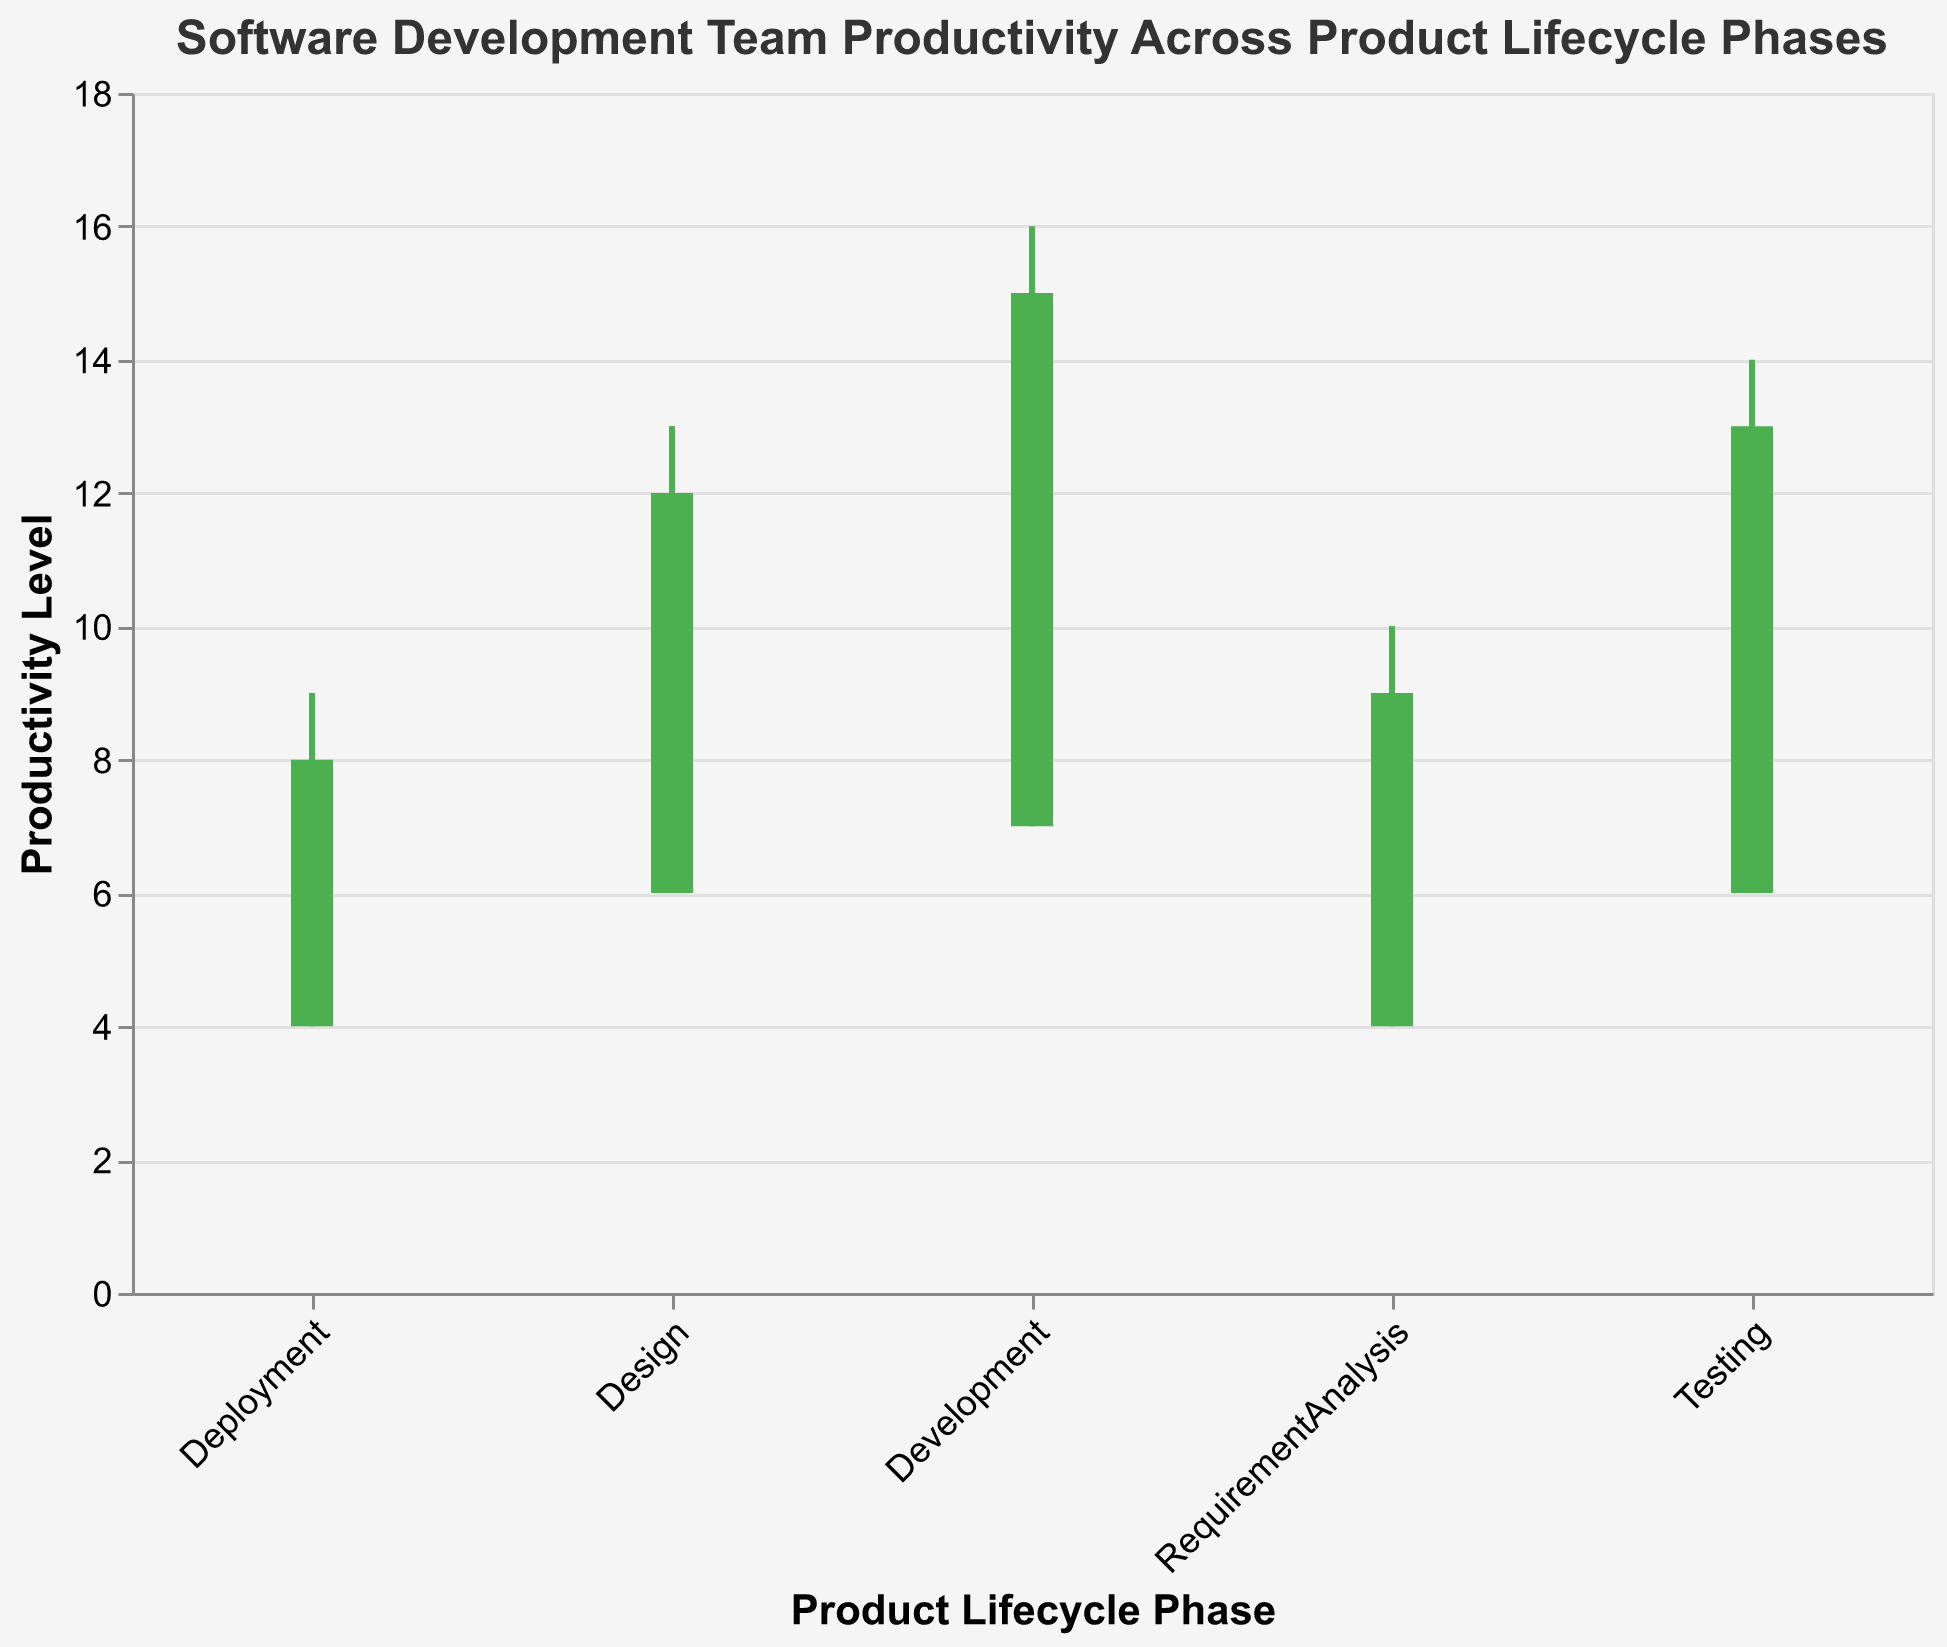What does the green color indicate in the candlestick plot? The green color in the candlestick plot indicates periods where the Close value is higher than the Open value, signifying an increase in productivity.
Answer: Increase in productivity What phase has the highest recorded productivity level? To find the highest productivity level, we look at the High values across all phases. The Development phase has the highest High value of 16.
Answer: Development What is the title of the plot? The title of the plot is directly displayed at the top of the figure.
Answer: Software Development Team Productivity Across Product Lifecycle Phases Which phase has the smallest range in productivity levels? The range of productivity levels can be found by subtracting the Low value from the High value. By checking each phase: RequirementAnalysis (10 - 4 = 6), Design (13 - 6 = 7), Development (16 - 7 = 9), Testing (14 - 6 = 8), Deployment (9 - 4 = 5). Deployment has the smallest range of 5
Answer: Deployment On average, how does productivity compare between the Design and Testing phases? To compare averages, calculate the High values' averages in both phases. Design: (12 + 13 + 11 + 13) / 4 = 12.25. Testing: (11 + 13 + 12 + 14) / 4 = 12.5. Testing averages slightly higher.
Answer: Testing is slightly higher During which phase do we observe the greatest increase in productivity? The greatest increase in productivity can be identified by the largest difference between Open and Close values. The Development phase has the highest increase with an Open of 7 and Close of 14 resulting in an increase of 7.
Answer: Development Which phase shows more consistent productivity levels between its Open and Close values? Consistency can be determined by the smallest variances in Open and Close values. RequirementAnalysis: (8-5, 7-4, 9-6, 7-5) with variances (3, 3, 3, 2). Design: (10-7, 11-8, 9-6, 12-9) with variances (3, 3, 3, 3). Development: (14-7, 13-8, 15-9, 12-10) with variances (7, 5, 6, 2). Testing: (10-6, 12-7, 11-8, 13-9) with variances (4, 5, 3, 4). Deployment: (6-4, 7-5, 8-6, 7-5) with variances (2, 2, 2, 2). Analysis shows Deployment is most consistent.
Answer: Deployment What is the average maximum productivity level during the Testing phase? Average maximum productivity level during Testing is (11 + 13 + 12 + 14) / 4 = 12.5.
Answer: 12.5 